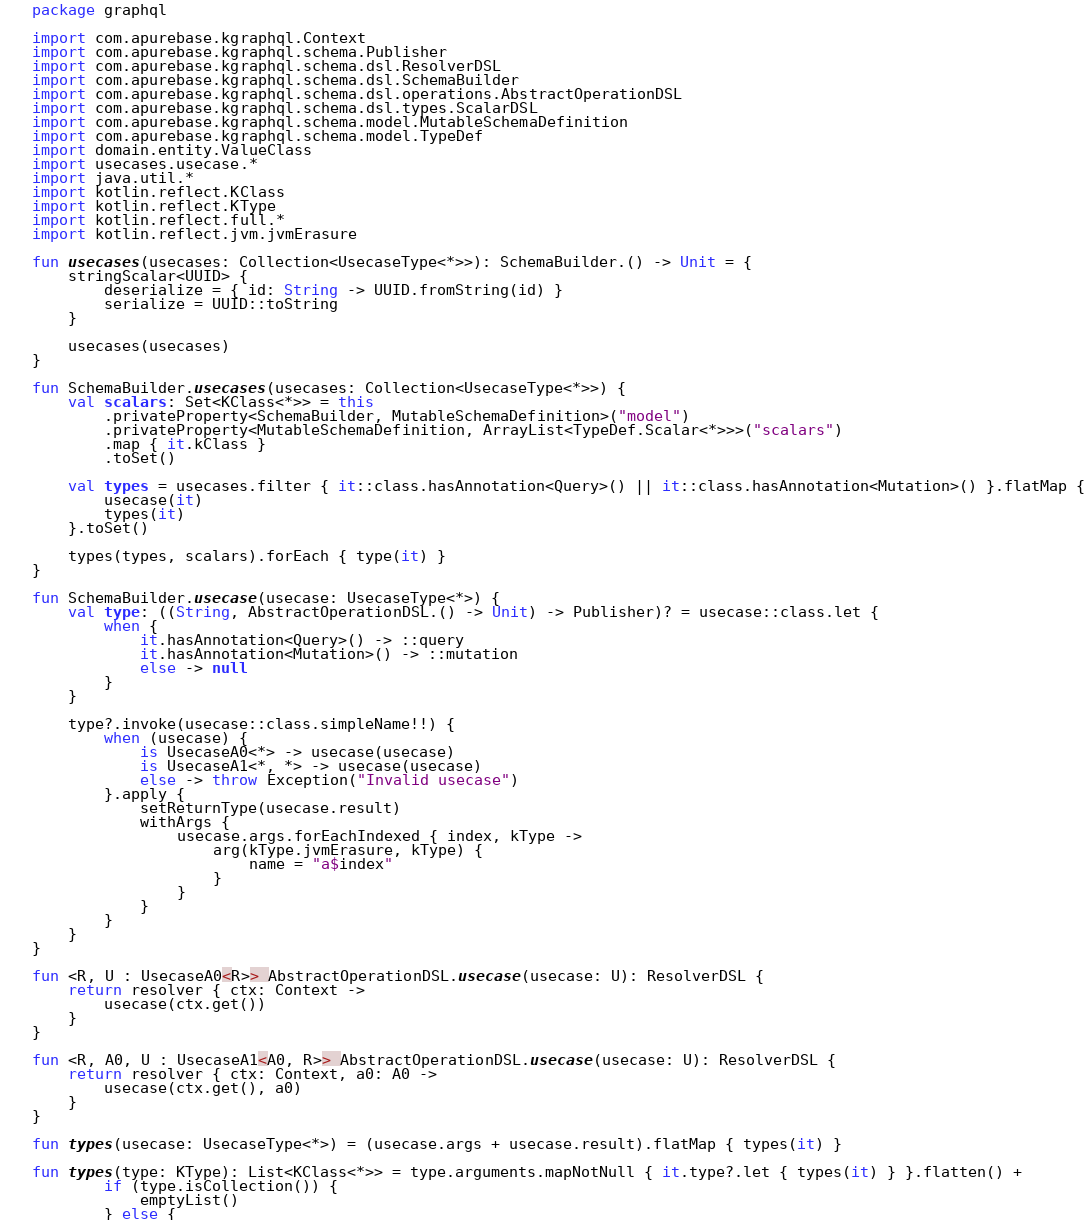Convert code to text. <code><loc_0><loc_0><loc_500><loc_500><_Kotlin_>package graphql

import com.apurebase.kgraphql.Context
import com.apurebase.kgraphql.schema.Publisher
import com.apurebase.kgraphql.schema.dsl.ResolverDSL
import com.apurebase.kgraphql.schema.dsl.SchemaBuilder
import com.apurebase.kgraphql.schema.dsl.operations.AbstractOperationDSL
import com.apurebase.kgraphql.schema.dsl.types.ScalarDSL
import com.apurebase.kgraphql.schema.model.MutableSchemaDefinition
import com.apurebase.kgraphql.schema.model.TypeDef
import domain.entity.ValueClass
import usecases.usecase.*
import java.util.*
import kotlin.reflect.KClass
import kotlin.reflect.KType
import kotlin.reflect.full.*
import kotlin.reflect.jvm.jvmErasure

fun usecases(usecases: Collection<UsecaseType<*>>): SchemaBuilder.() -> Unit = {
    stringScalar<UUID> {
        deserialize = { id: String -> UUID.fromString(id) }
        serialize = UUID::toString
    }

    usecases(usecases)
}

fun SchemaBuilder.usecases(usecases: Collection<UsecaseType<*>>) {
    val scalars: Set<KClass<*>> = this
        .privateProperty<SchemaBuilder, MutableSchemaDefinition>("model")
        .privateProperty<MutableSchemaDefinition, ArrayList<TypeDef.Scalar<*>>>("scalars")
        .map { it.kClass }
        .toSet()

    val types = usecases.filter { it::class.hasAnnotation<Query>() || it::class.hasAnnotation<Mutation>() }.flatMap {
        usecase(it)
        types(it)
    }.toSet()

    types(types, scalars).forEach { type(it) }
}

fun SchemaBuilder.usecase(usecase: UsecaseType<*>) {
    val type: ((String, AbstractOperationDSL.() -> Unit) -> Publisher)? = usecase::class.let {
        when {
            it.hasAnnotation<Query>() -> ::query
            it.hasAnnotation<Mutation>() -> ::mutation
            else -> null
        }
    }

    type?.invoke(usecase::class.simpleName!!) {
        when (usecase) {
            is UsecaseA0<*> -> usecase(usecase)
            is UsecaseA1<*, *> -> usecase(usecase)
            else -> throw Exception("Invalid usecase")
        }.apply {
            setReturnType(usecase.result)
            withArgs {
                usecase.args.forEachIndexed { index, kType ->
                    arg(kType.jvmErasure, kType) {
                        name = "a$index"
                    }
                }
            }
        }
    }
}

fun <R, U : UsecaseA0<R>> AbstractOperationDSL.usecase(usecase: U): ResolverDSL {
    return resolver { ctx: Context ->
        usecase(ctx.get())
    }
}

fun <R, A0, U : UsecaseA1<A0, R>> AbstractOperationDSL.usecase(usecase: U): ResolverDSL {
    return resolver { ctx: Context, a0: A0 ->
        usecase(ctx.get(), a0)
    }
}

fun types(usecase: UsecaseType<*>) = (usecase.args + usecase.result).flatMap { types(it) }

fun types(type: KType): List<KClass<*>> = type.arguments.mapNotNull { it.type?.let { types(it) } }.flatten() +
        if (type.isCollection()) {
            emptyList()
        } else {</code> 